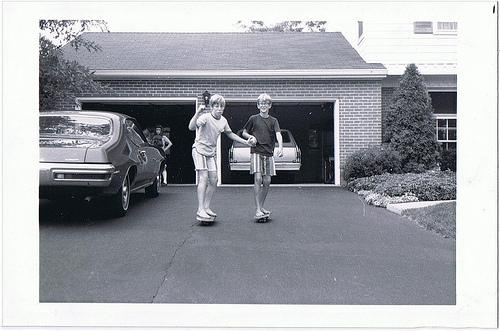What are the two boys doing in the driveway? Two boys are holding hands and skateboarding in the driveway. What is the state of the leaves on the tree mentioned in the image description? The leaves on the tree are green in color. Count the number of boys and cars in the image. There are two boys and two cars in the image. Mention the type of car parked in the driveway and point out one of its parts. There is a car parked in the driveway with a visible window, and tree branches can be seen above it. Identify one specific component of a skateboard mentioned in the image description. A wheel is mentioned as a component of a skateboard in the description. Explain the interaction happening between the two boys skateboarding. The two boys are holding hands while skateboarding, showing a sense of camaraderie and friendship. Describe the outfit of the boy wearing t-shirt and shorts. The boy is wearing a dark t-shirt, possibly with glasses, and striped shorts while riding a skateboard. What is the material of the wall in the image and what is connected to it? The wall is made of bricks, and it is connected to a house attached to a garage. Can you provide a brief description of the image focusing on the garage? There is a two-door brick garage with a dark roof and a station wagon parked inside. A tall pine tree stands next to it, and two boys skateboard in the driveway in front. Analyze the emotion or sentiment evoked by the image. The image evokes a feeling of joy and playfulness, as two young boys are enjoying themselves skateboarding together in a driveway. What are the objects present in the image with X coordinate between 140 and 300 and Y coordinate between 80 and 100? Boy on a skateboard, boy wearing a t-shirt and shorts, two boys in front of a garage. Is the yellow fire hydrant beside the tree on the left side of the house noticeable? Describe its condition. No, it's not mentioned in the image. Are there any unusual objects or anomalies present in the image? No, all objects and elements in the image appear to be normal and relevant. Are there any skateboards in the image, and if so, what is their position? Yes, there are skateboards in the image, they are under the boys skateboarding in the driveway and at (X:252, Y:212). Is there a house attached to the garage? Yes, there is a house attached to the garage. Find the object with coordinates (X:187, Y:86) and provide its caption. Two boys holding hands skateboarding. Identify the object with dimensions (Width:64, Height:64) and give its location (X, Y). The object is a wheel on the car, located at (X:105, Y:162). How many boys are on skateboards in the image? Two boys are on skateboards in the image. Based on the provided information, can you identify any interactions between objects in the image? Yes, two boys are holding hands and skateboarding together in the driveway. What is the attribute of the tree at (X:401, Y:83)? The leaves are green in color. Evaluate the overall quality of the image. The image quality is clear and well-defined. What is the color of the boy's T-shirt at (X:180, Y:62)? The boy is wearing a dark T-shirt. Is there a car parked in the driveway, and does it have visible tail lights? Yes, there is a car parked in the driveway and its tail light is visible. Describe the scene involving two boys in the image. Two boys are holding hands, skateboarding in a driveway in front of a garage. Describe the color and location of the roof. The roof is dark-colored and located above the garage. In a multiple-choice question, determine whether the garage is made of bricks or wood, based on the information given. The garage is made of bricks. What type of tree is next to the garage? A tall pine tree. What is the object located at (X:242, Y:110) in the image? Dark tshirt on a kid with glasses on a skateboard. What is the object at coordinates (X:34, Y:109)? Window on the car. What is the material of the wall in the image? The wall is made of bricks. 